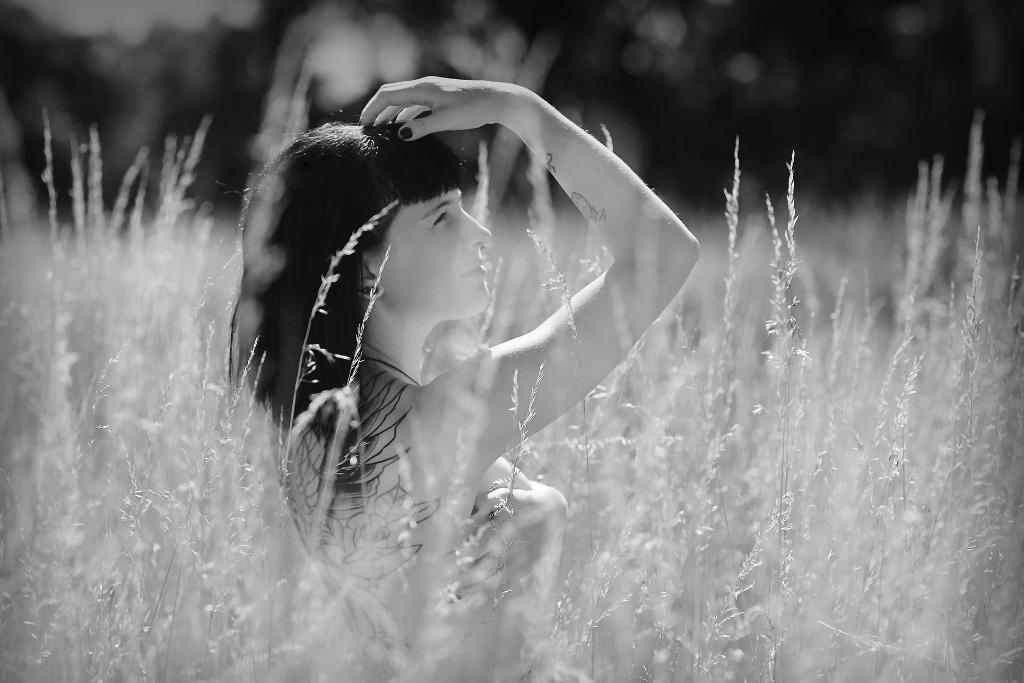What is the color scheme of the image? The image is black and white. Can you describe the main subject of the image? There is a lady in the image. Where is the lady located in the image? The lady is inside plants. How would you describe the background of the image? The background of the image is blurred. What type of lunchroom can be seen in the background of the image? There is no lunchroom present in the image; it is a black and white image of a lady inside plants with a blurred background. Can you hear the band playing in the image? There is no band present in the image, so it is not possible to hear them playing. 